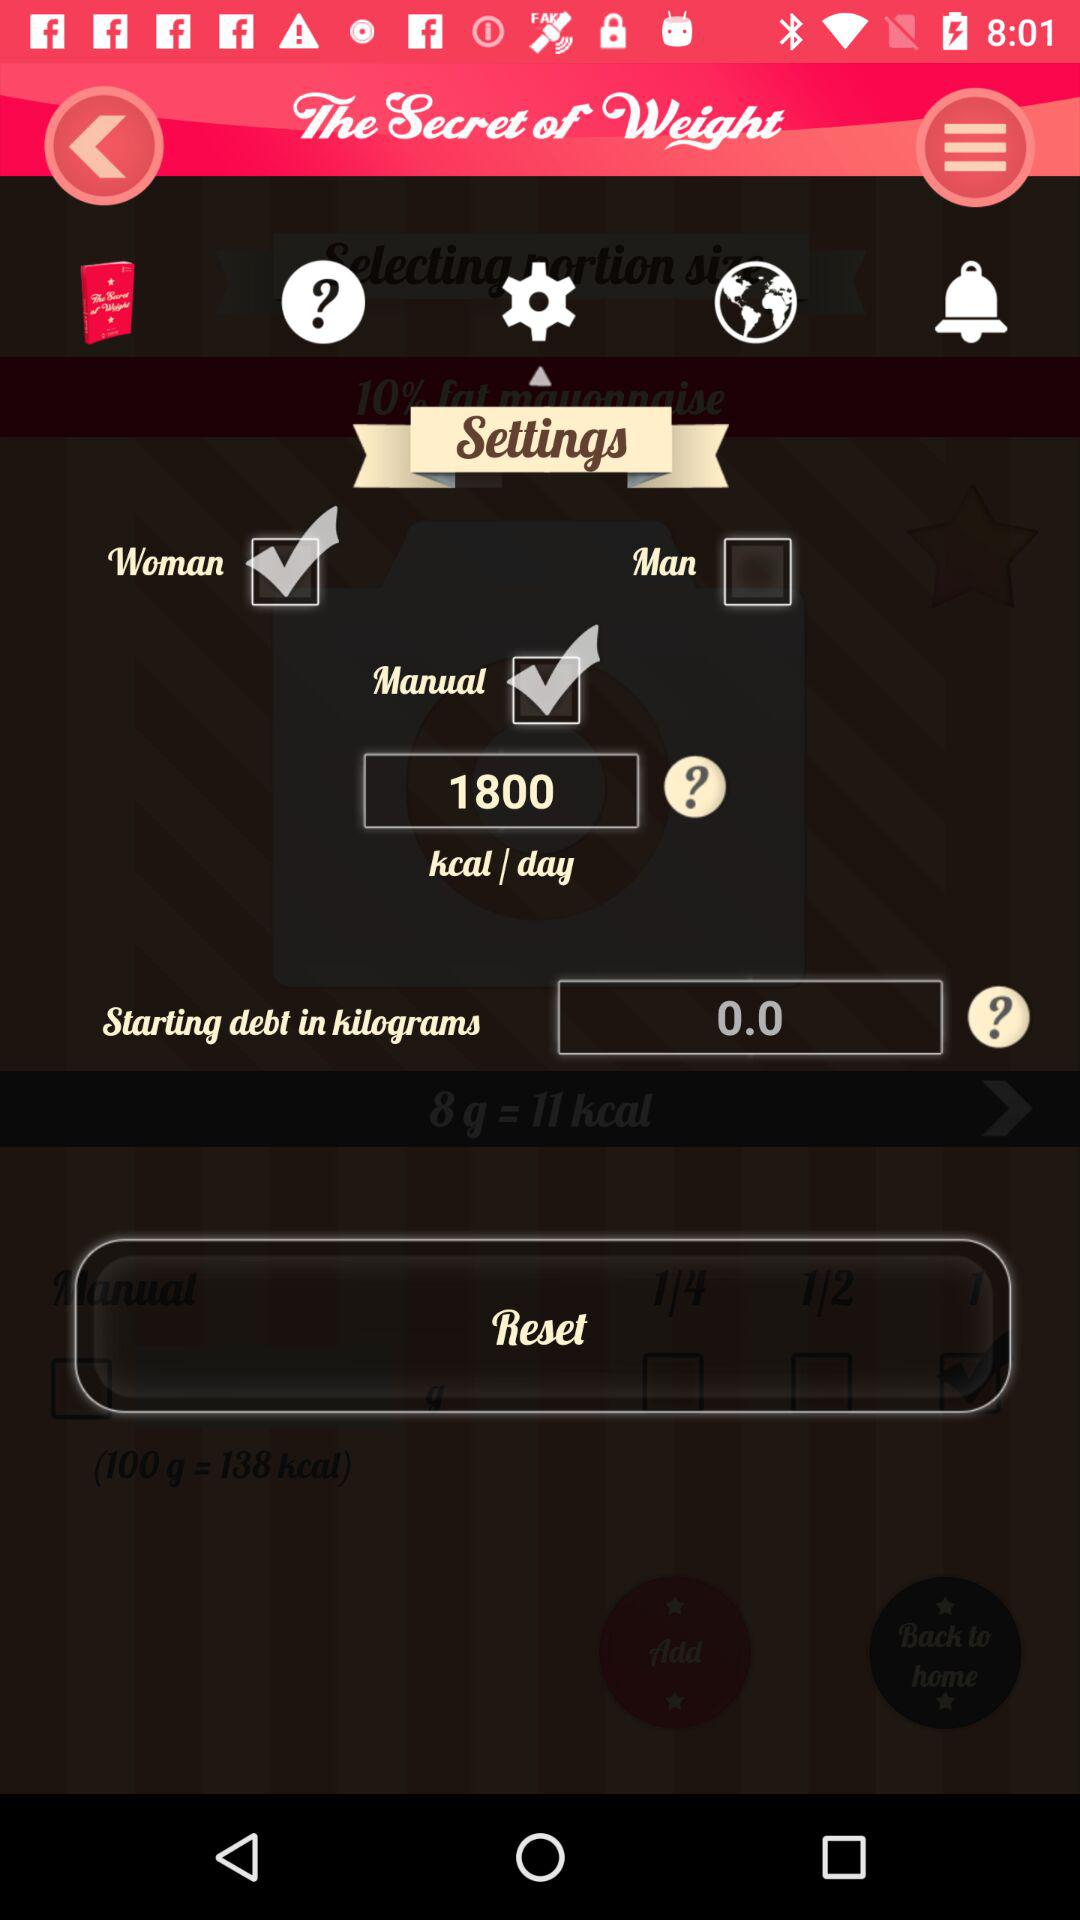How many kilograms of starting debt are there?
Answer the question using a single word or phrase. 0.0 